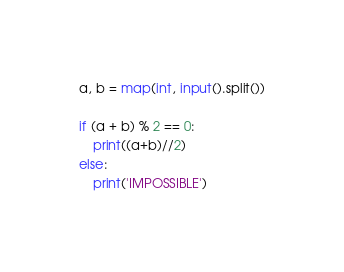Convert code to text. <code><loc_0><loc_0><loc_500><loc_500><_Python_>a, b = map(int, input().split())

if (a + b) % 2 == 0:
    print((a+b)//2)
else:
    print('IMPOSSIBLE')</code> 